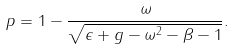Convert formula to latex. <formula><loc_0><loc_0><loc_500><loc_500>p = 1 - { \frac { \omega } { \sqrt { \epsilon + g - \omega ^ { 2 } - \beta - 1 } } } .</formula> 